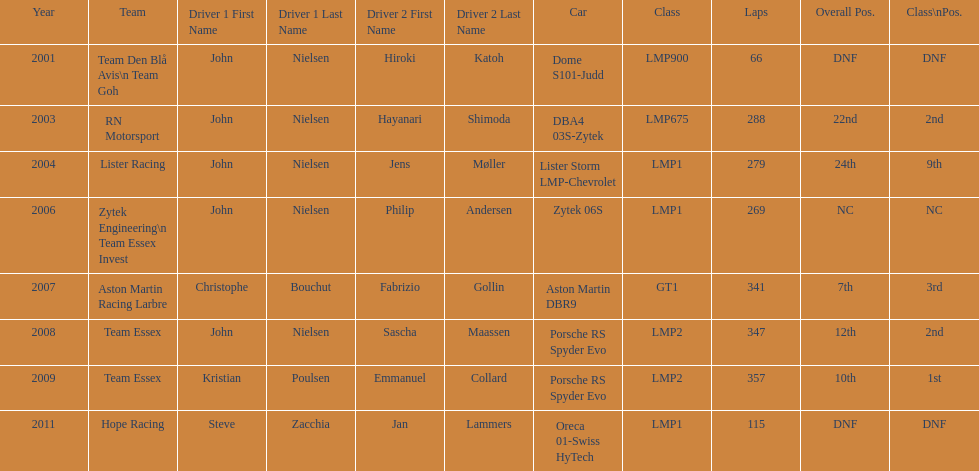How many times was the porsche rs spyder used in competition? 2. Parse the full table. {'header': ['Year', 'Team', 'Driver 1 First Name', 'Driver 1 Last Name', 'Driver 2 First Name', 'Driver 2 Last Name', 'Car', 'Class', 'Laps', 'Overall Pos.', 'Class\\nPos.'], 'rows': [['2001', 'Team Den Blå Avis\\n Team Goh', 'John', 'Nielsen', 'Hiroki', 'Katoh', 'Dome S101-Judd', 'LMP900', '66', 'DNF', 'DNF'], ['2003', 'RN Motorsport', 'John', 'Nielsen', 'Hayanari', 'Shimoda', 'DBA4 03S-Zytek', 'LMP675', '288', '22nd', '2nd'], ['2004', 'Lister Racing', 'John', 'Nielsen', 'Jens', 'Møller', 'Lister Storm LMP-Chevrolet', 'LMP1', '279', '24th', '9th'], ['2006', 'Zytek Engineering\\n Team Essex Invest', 'John', 'Nielsen', 'Philip', 'Andersen', 'Zytek 06S', 'LMP1', '269', 'NC', 'NC'], ['2007', 'Aston Martin Racing Larbre', 'Christophe', 'Bouchut', 'Fabrizio', 'Gollin', 'Aston Martin DBR9', 'GT1', '341', '7th', '3rd'], ['2008', 'Team Essex', 'John', 'Nielsen', 'Sascha', 'Maassen', 'Porsche RS Spyder Evo', 'LMP2', '347', '12th', '2nd'], ['2009', 'Team Essex', 'Kristian', 'Poulsen', 'Emmanuel', 'Collard', 'Porsche RS Spyder Evo', 'LMP2', '357', '10th', '1st'], ['2011', 'Hope Racing', 'Steve', 'Zacchia', 'Jan', 'Lammers', 'Oreca 01-Swiss HyTech', 'LMP1', '115', 'DNF', 'DNF']]} 